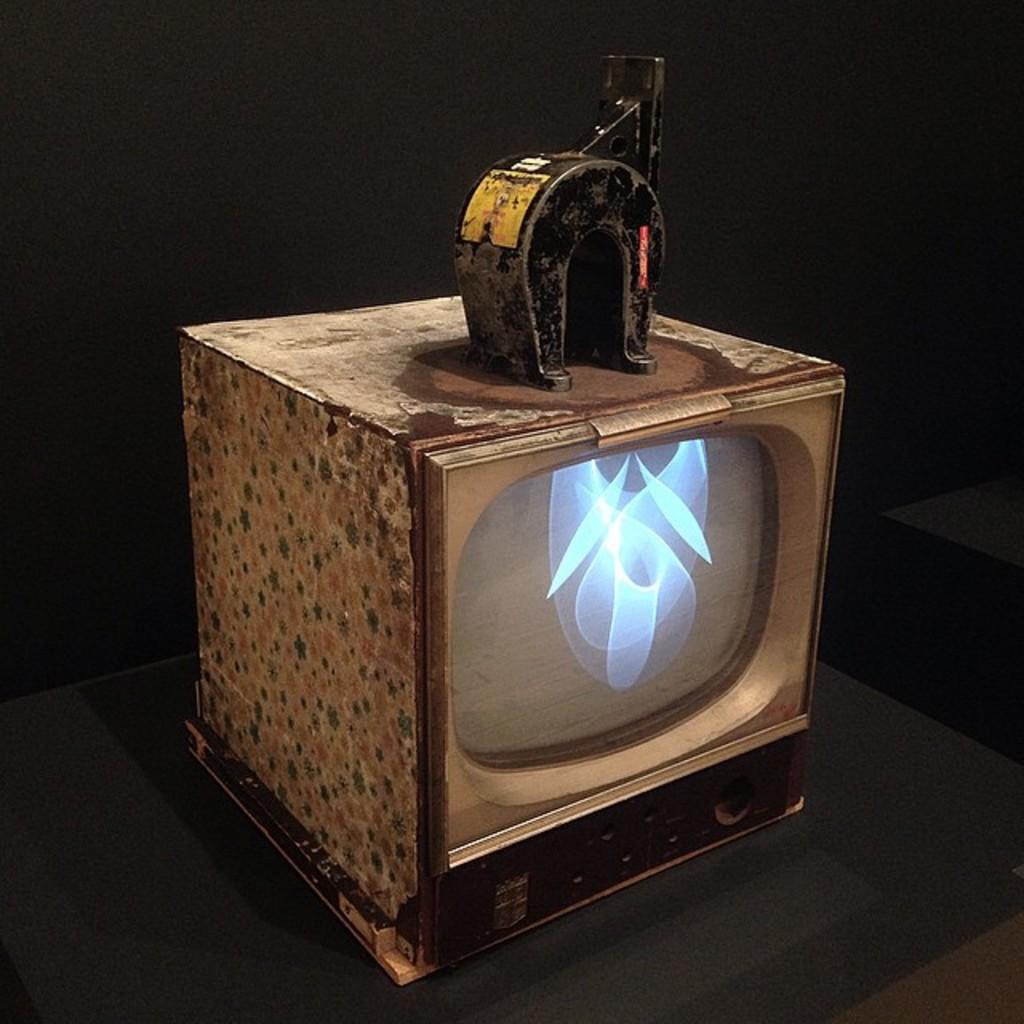What type of electronic device is present in the image? There is an old television in the image. What is placed on top of the television? There is an iron object on top of the television. Can you describe the background of the image? The background of the image is dark. What type of jewel is being offered as advice in the image? There is no jewel or advice present in the image; it only features an old television with an iron object on top. 